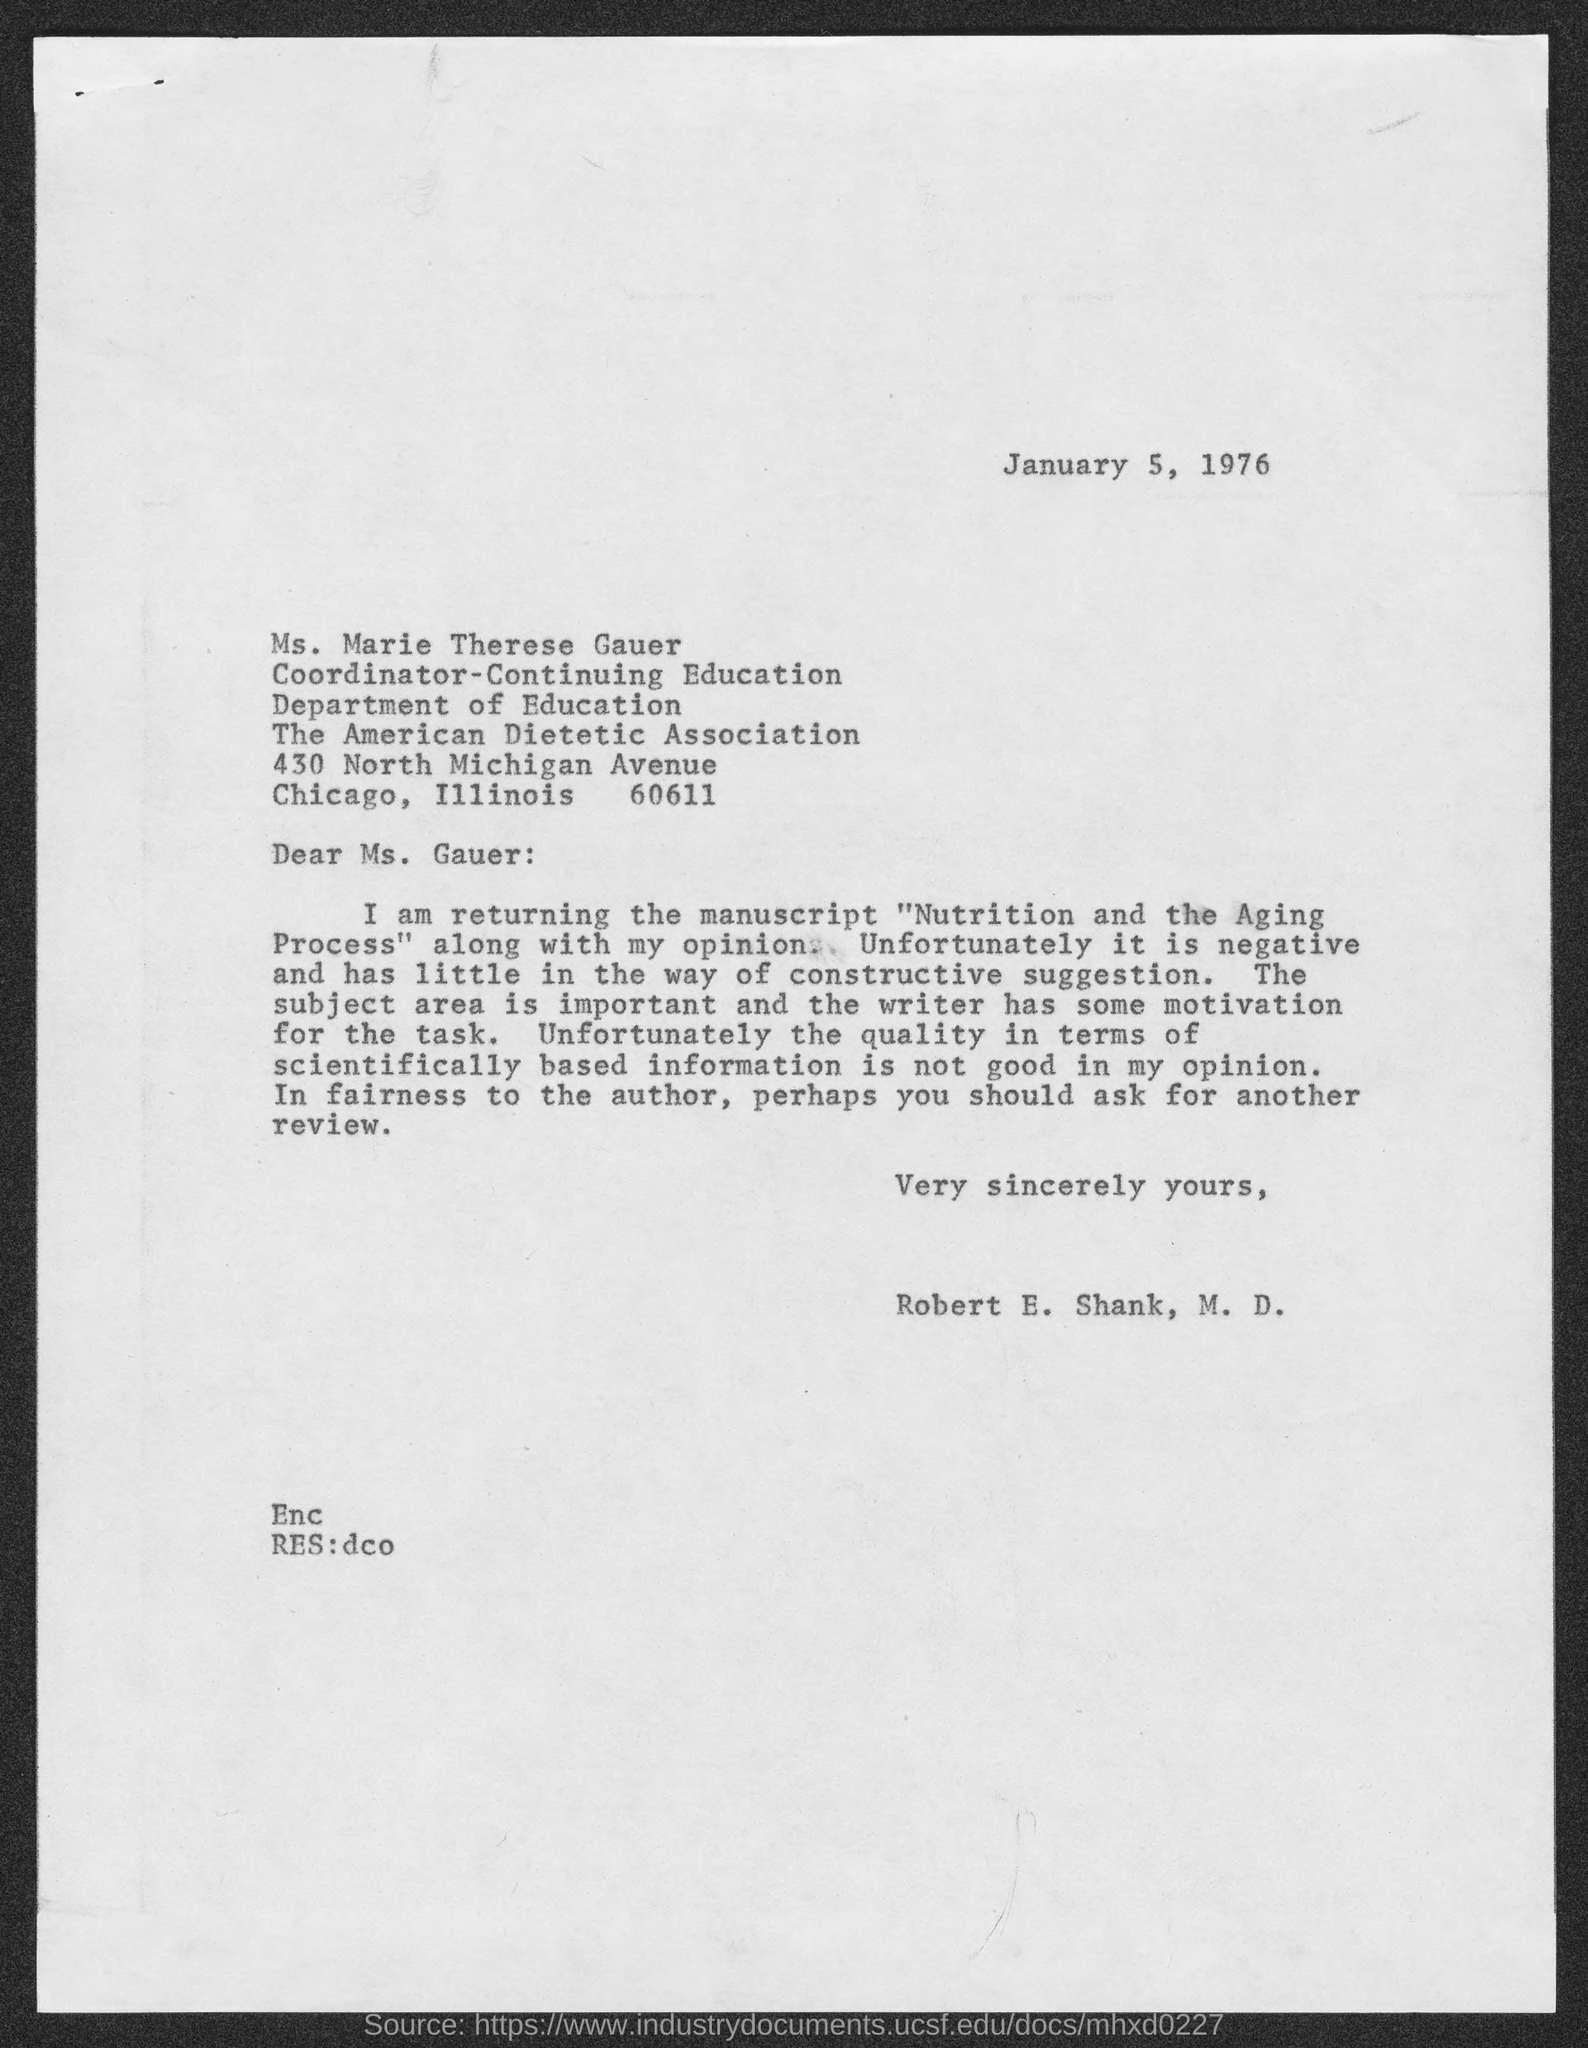Specify some key components in this picture. The memorandum is addressed to Ms. Gauer. The memorandum is dated January 5, 1976. 